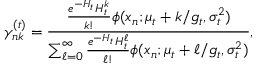Convert formula to latex. <formula><loc_0><loc_0><loc_500><loc_500>\gamma _ { n k } ^ { ( t ) } = \frac { \frac { e ^ { - H _ { t } } H _ { t } ^ { k } } { k ! } \phi ( x _ { n } ; \mu _ { t } + k / g _ { t } , \sigma _ { t } ^ { 2 } ) } { \sum _ { \ell = 0 } ^ { \infty } \frac { e ^ { - H _ { t } } H _ { t } ^ { \ell } } { \ell ! } \phi ( x _ { n } ; \mu _ { t } + \ell / g _ { t } , \sigma _ { t } ^ { 2 } ) } ,</formula> 